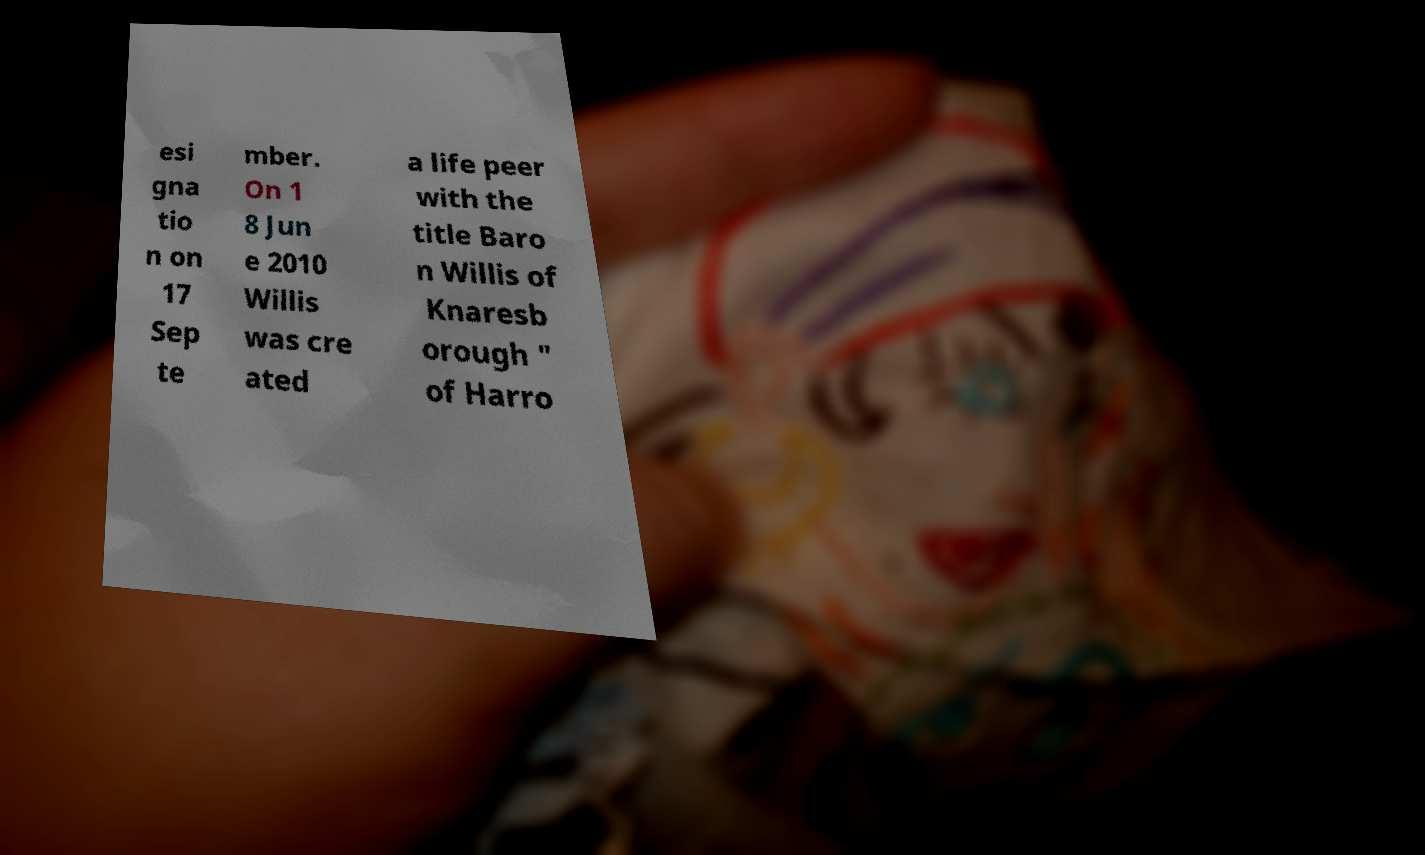Please read and relay the text visible in this image. What does it say? esi gna tio n on 17 Sep te mber. On 1 8 Jun e 2010 Willis was cre ated a life peer with the title Baro n Willis of Knaresb orough " of Harro 